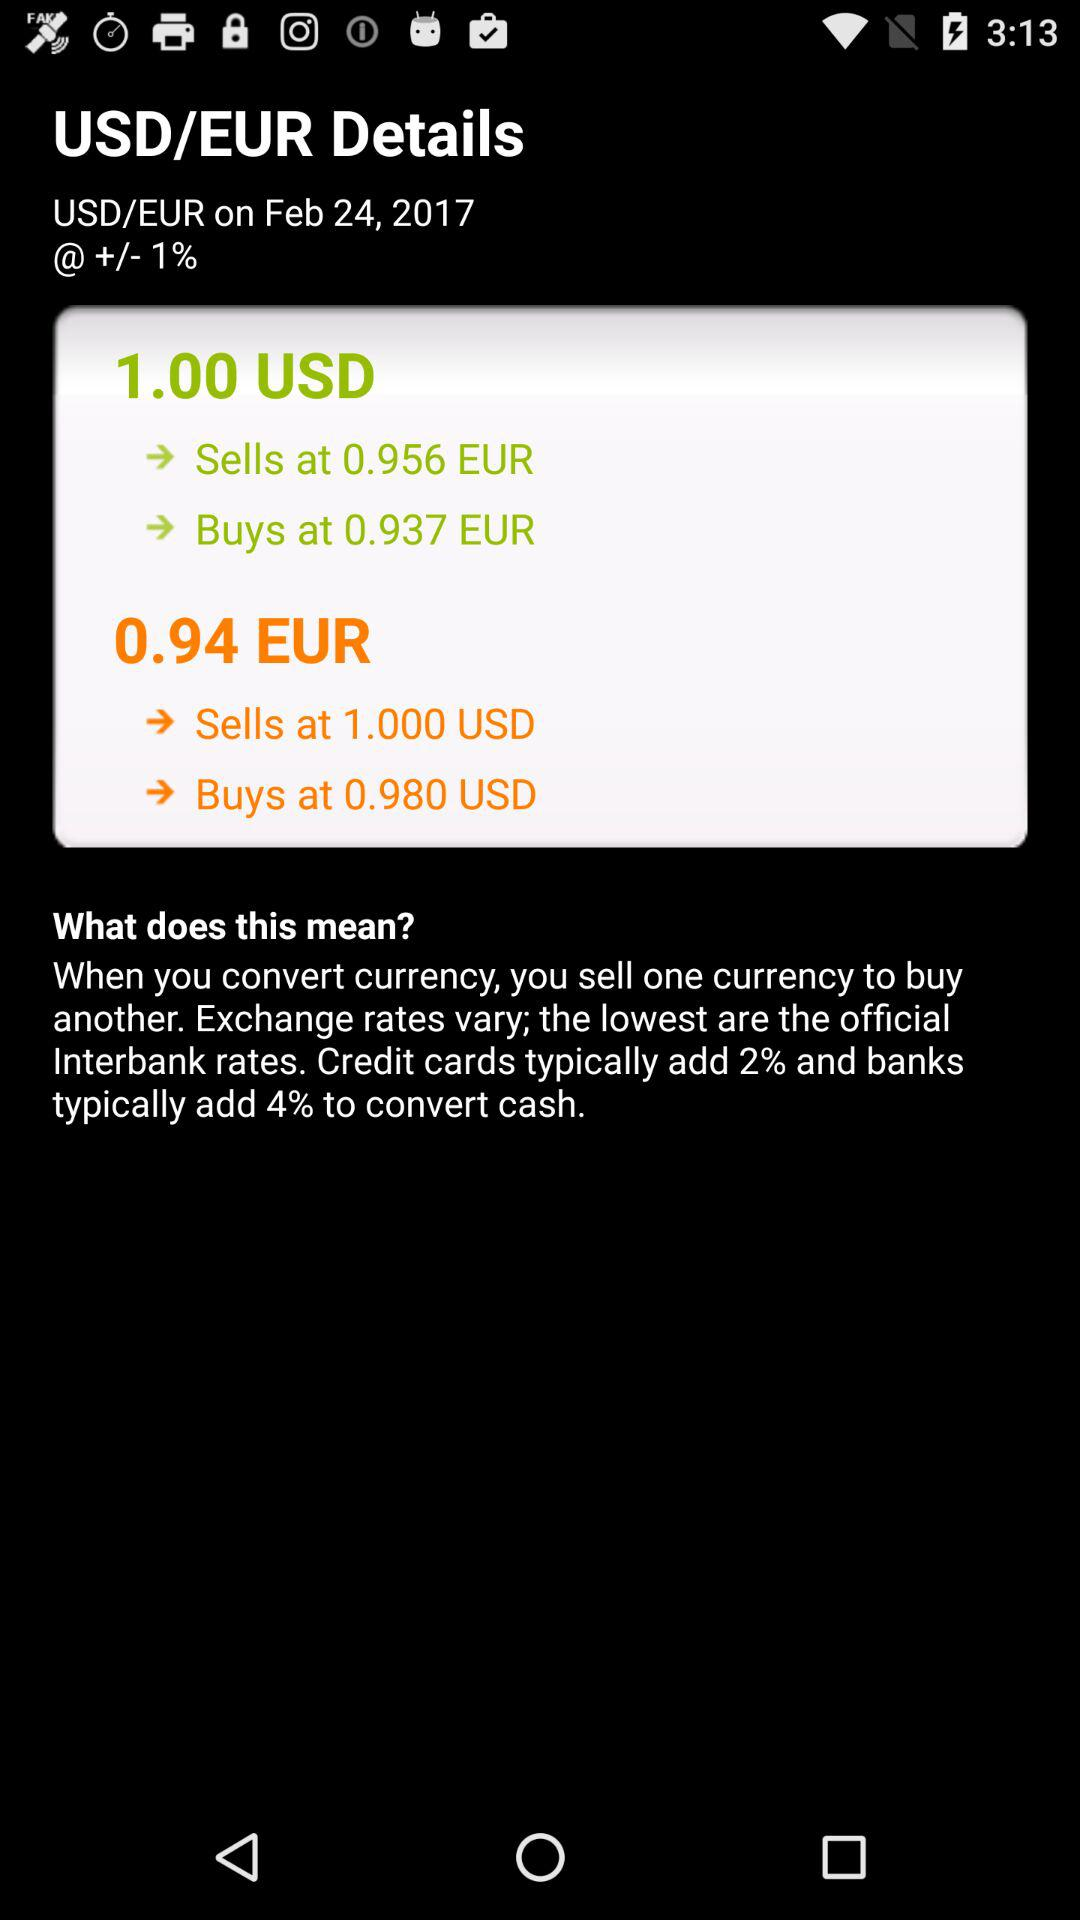What is the selling price of a euro against $1? The selling price is 0.956 euros. 